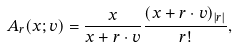<formula> <loc_0><loc_0><loc_500><loc_500>A _ { r } ( x ; v ) = \frac { x } { x + r \cdot v } \frac { ( x + r \cdot v ) _ { | r | } } { r ! } ,</formula> 